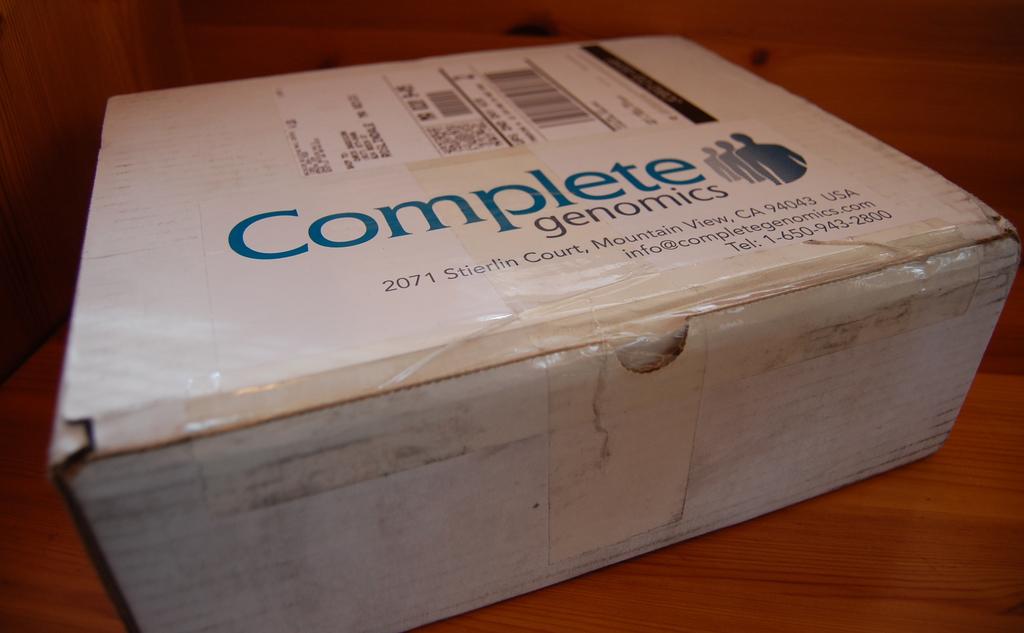What company is on the box?
Your response must be concise. Complete genomics. What is the telephone number of the company?
Ensure brevity in your answer.  1-650-943-2800. 